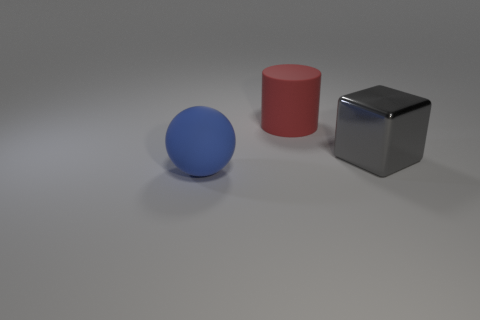What number of other things are there of the same color as the cylinder?
Offer a very short reply. 0. Is the size of the thing on the right side of the big red rubber thing the same as the matte thing right of the blue ball?
Give a very brief answer. Yes. What is the color of the big thing that is right of the matte cylinder?
Offer a very short reply. Gray. Are there fewer large gray things on the right side of the ball than green balls?
Ensure brevity in your answer.  No. Do the red cylinder and the blue thing have the same material?
Provide a short and direct response. Yes. What number of things are matte things that are right of the large blue thing or matte things on the left side of the red cylinder?
Offer a very short reply. 2. Are there fewer big metallic blocks than matte things?
Offer a very short reply. Yes. Do the red cylinder and the rubber object that is on the left side of the red thing have the same size?
Provide a succinct answer. Yes. What number of metal objects are either blue things or big green balls?
Offer a very short reply. 0. Is the number of big yellow rubber spheres greater than the number of big blocks?
Offer a terse response. No. 